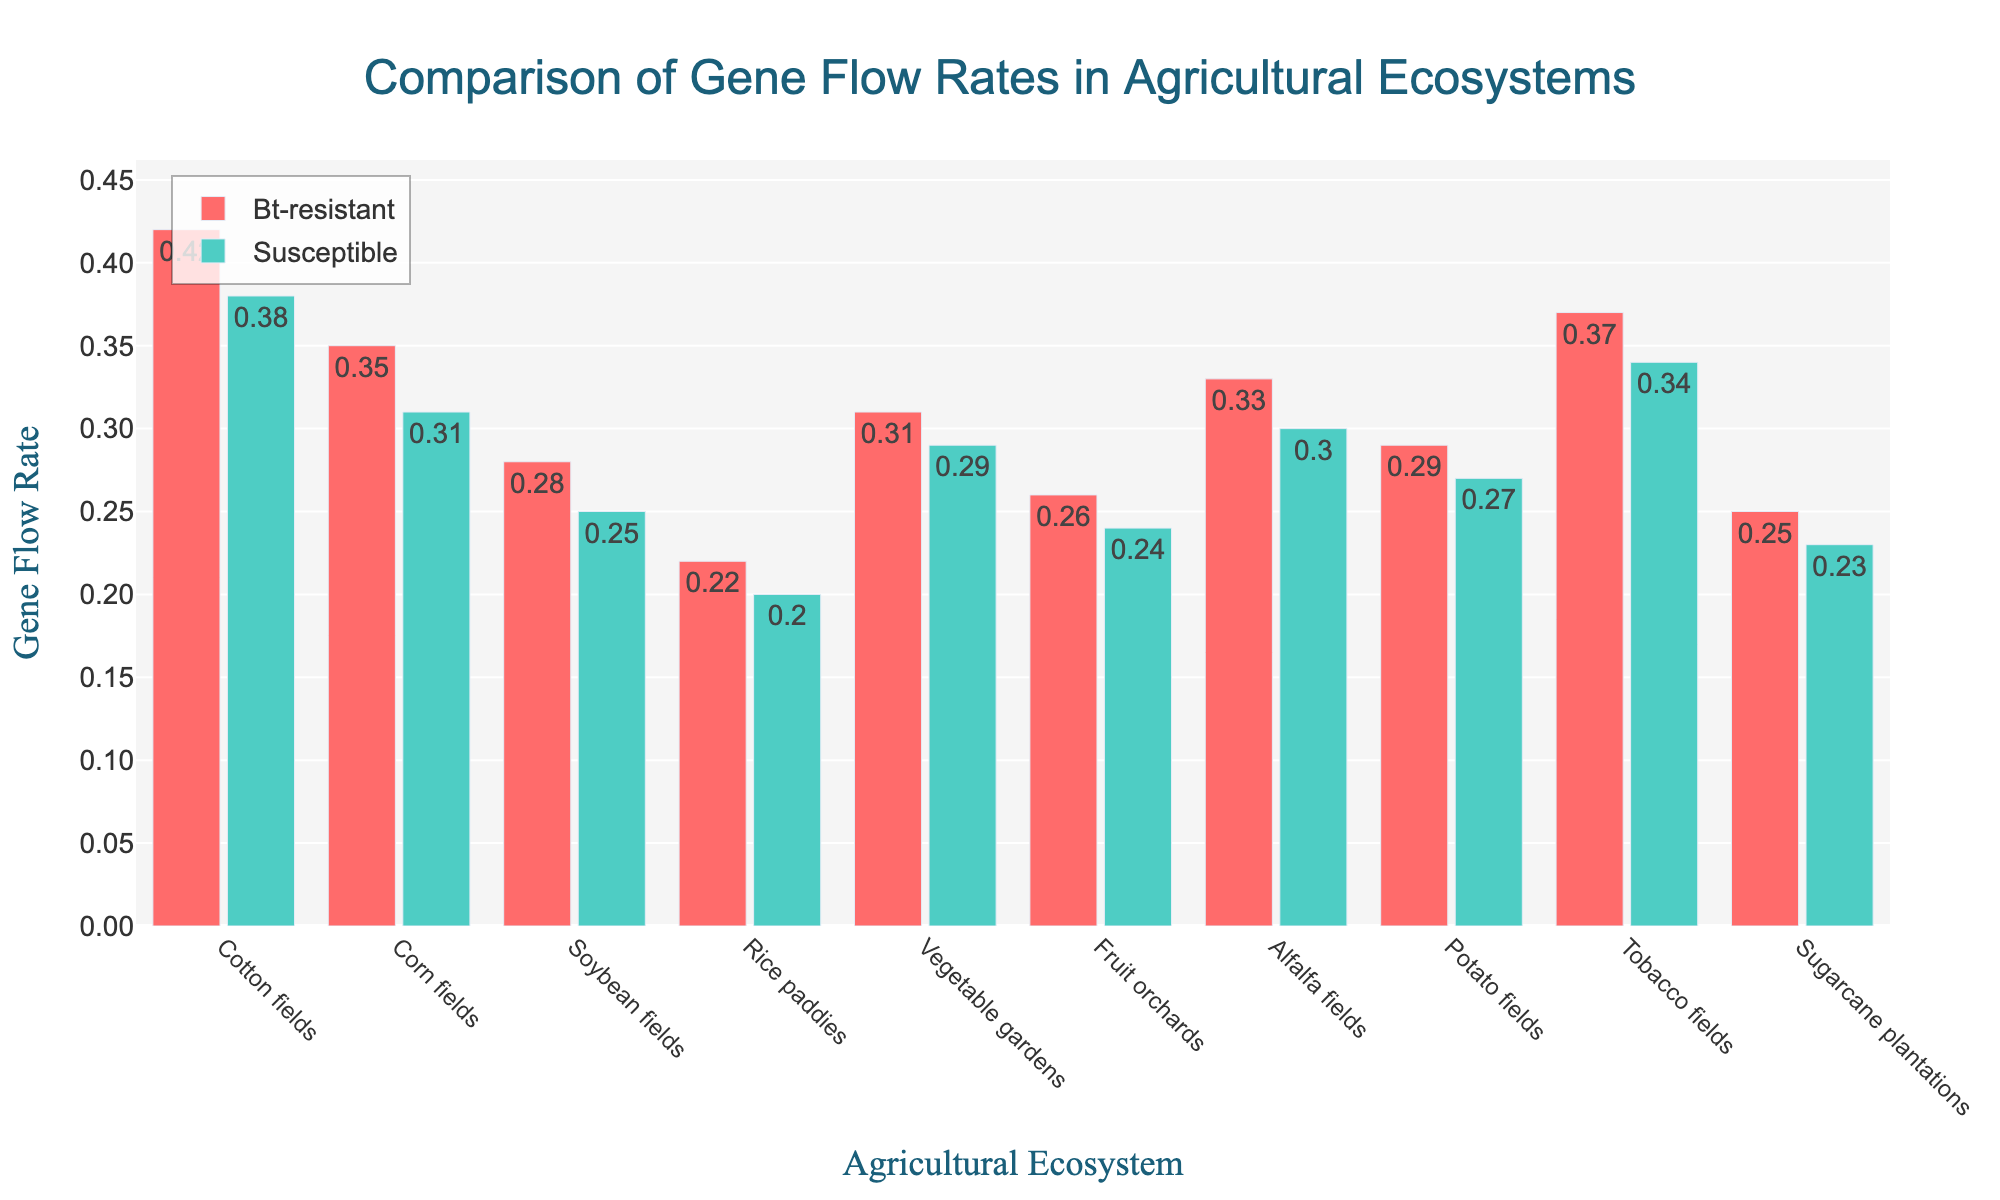What is the difference in gene flow rates between Bt-resistant and susceptible populations in Cotton fields? The bar for Bt-resistant gene flow in Cotton fields is at 0.42, and the bar for susceptible gene flow is at 0.38. The difference is calculated by subtracting the susceptible gene flow rate from the Bt-resistant gene flow rate: 0.42 - 0.38 = 0.04
Answer: 0.04 Which ecosystem has the highest Bt-resistant gene flow rate, and what is its value? The tallest red bar represents the highest Bt-resistant gene flow rate, which is in the Cotton fields. The value is indicated directly on the bar as 0.42
Answer: Cotton fields, 0.42 What is the average gene flow rate for Bt-resistant populations across all ecosystems? To find the average, sum the Bt-resistant gene flow rates across all ecosystems and divide by the number of ecosystems. (0.42 + 0.35 + 0.28 + 0.22 + 0.31 + 0.26 + 0.33 + 0.29 + 0.37 + 0.25) / 10 = 3.08 / 10 = 0.308
Answer: 0.308 In which ecosystem do Bt-resistant and susceptible populations have the smallest difference in gene flow rates? The smallest difference is in Rice paddies, where the gene flow rates are 0.22 (Bt-resistant) and 0.20 (susceptible). The difference is calculated as 0.22 - 0.20 = 0.02
Answer: Rice paddies For which ecosystem is the gene flow rate of susceptible populations greater than 0.30? By looking at the green bars and their values, the only ecosystem where the susceptible gene flow rate is greater than 0.30 is Cotton fields, with a value of 0.38
Answer: Cotton fields What is the sum of gene flow rates for Bt-resistant and susceptible populations in Corn fields? Sum the Bt-resistant and susceptible gene flow rates for Corn fields: 0.35 (Bt-resistant) + 0.31 (susceptible) = 0.66
Answer: 0.66 Which ecosystem shows the greatest difference in gene flow rates between Bt-resistant and susceptible populations? The greatest difference is observed in Cotton fields, where the gene flow rates are 0.42 (Bt-resistant) and 0.38 (susceptible). The difference is calculated as 0.42 - 0.38 = 0.04
Answer: Cotton fields Compare the gene flow rates between Bt-resistant populations in Potato fields and Tobacco fields. Which one is higher, and by how much? The Bt-resistant gene flow rate in Potato fields is 0.29 and in Tobacco fields is 0.37. The difference is calculated as 0.37 - 0.29 = 0.08, indicating that it is higher in Tobacco fields by 0.08
Answer: Tobacco fields, 0.08 Which agricultural ecosystem has the lowest gene flow rate for susceptible populations, and what is the value? The lowest green bar represents the lowest susceptible gene flow rate, which is in Rice paddies. The value is indicated directly on the bar as 0.20
Answer: Rice paddies, 0.20 